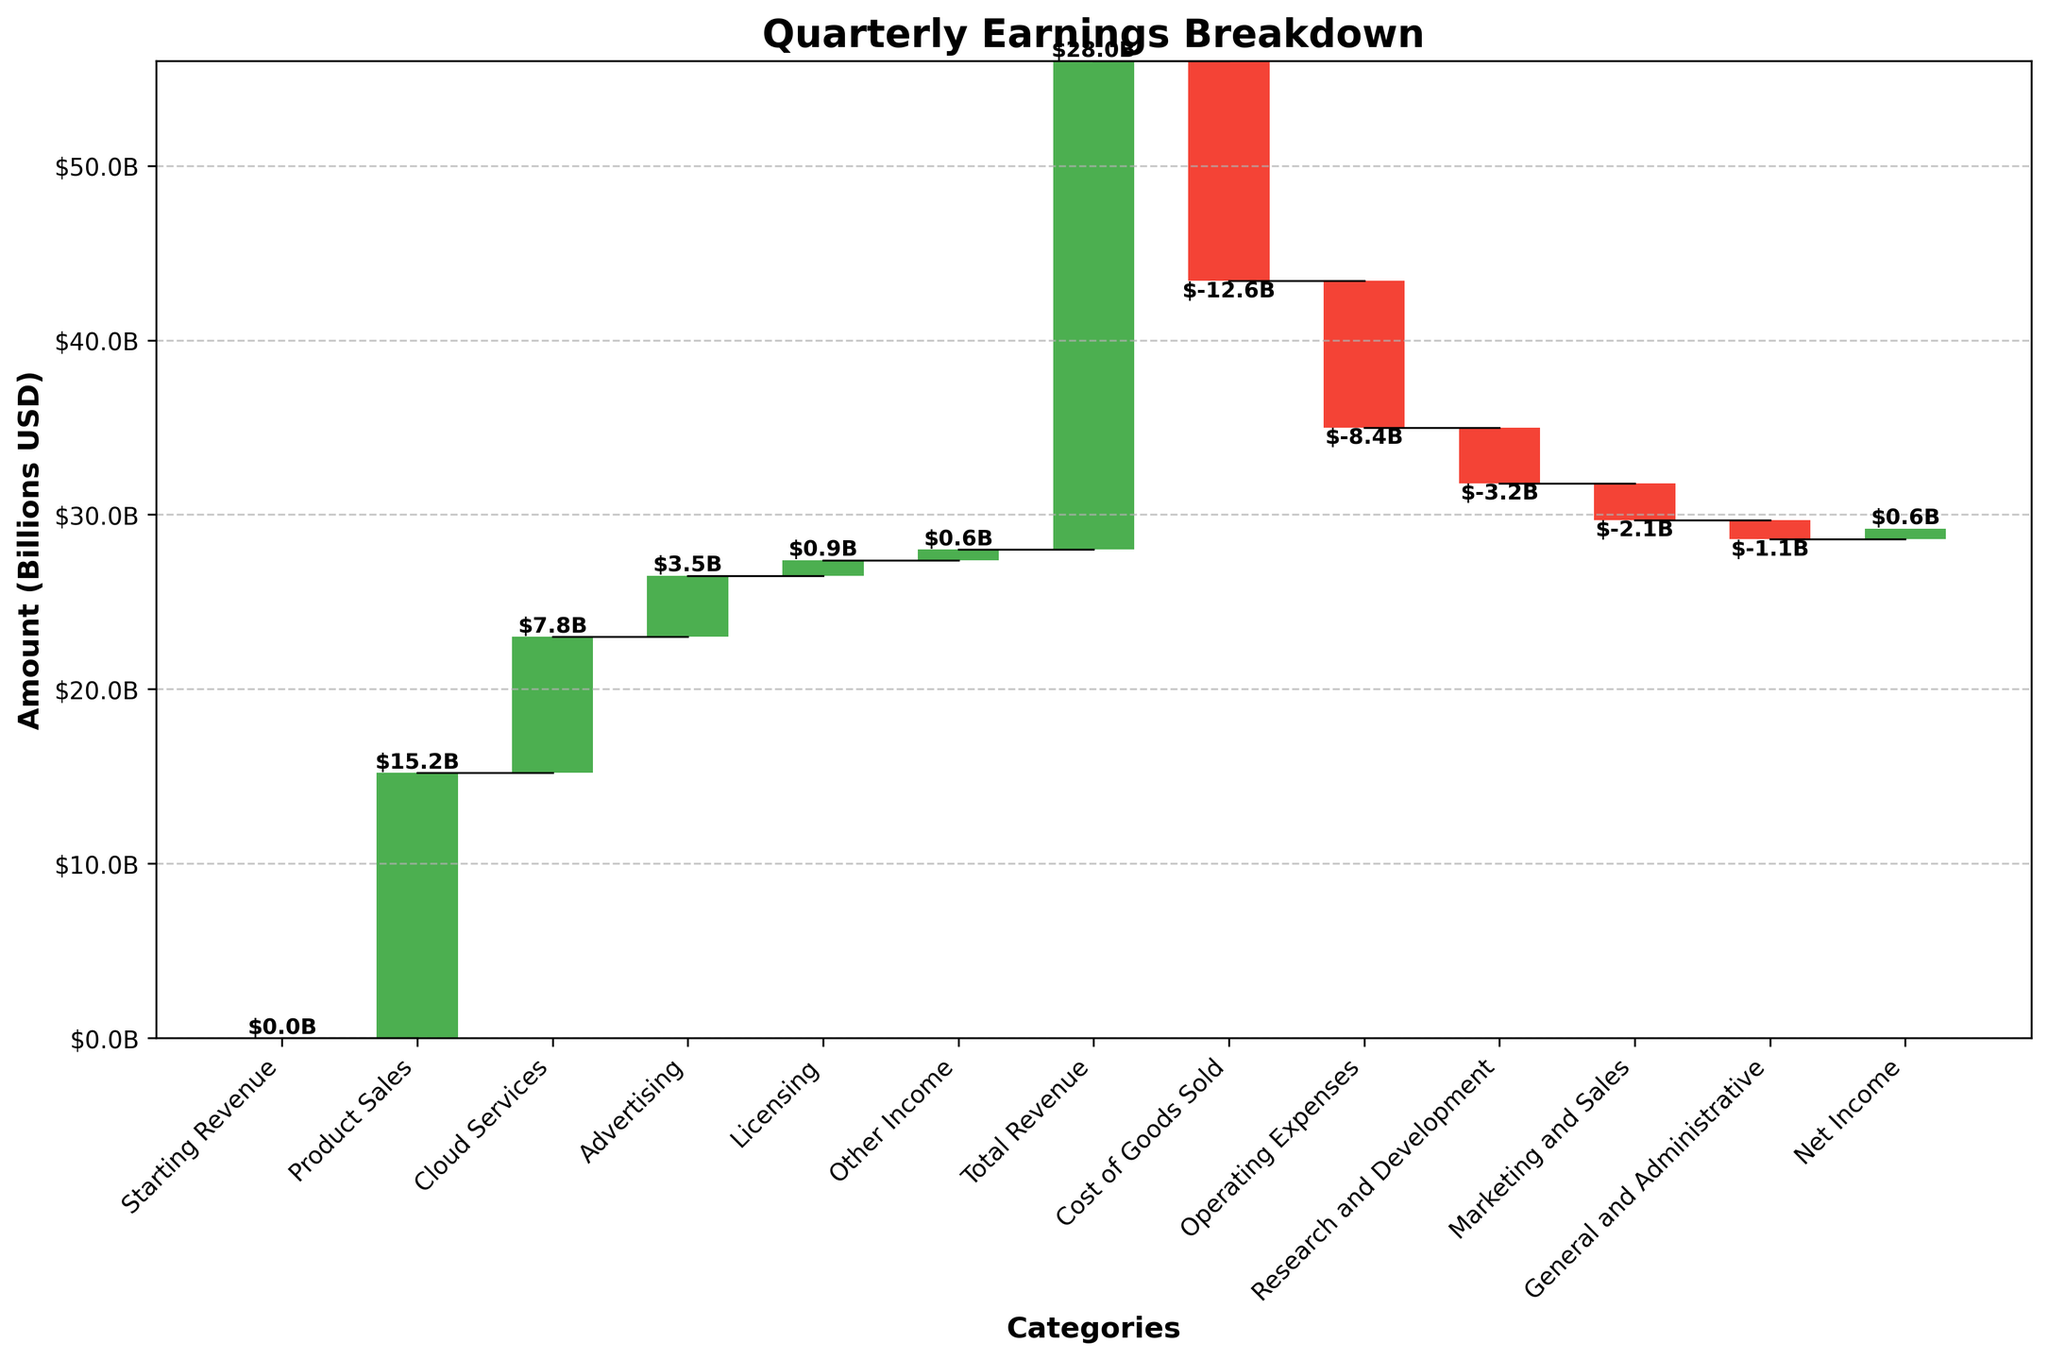What does the title of the Waterfall Chart mention? The title of the chart is located at the top and usually describes the overall subject of the chart. This particular chart's title provides context about what the data represents.
Answer: Quarterly Earnings Breakdown What is the total revenue as shown in the Waterfall Chart? The total revenue is represented as a single bar towards the beginning sections of the chart and is distinctly labeled. By looking at this bar's label, one can identify the total revenue amount.
Answer: $28.0B Why is "Cost of Goods Sold" represented with a red bar? In a Waterfall Chart, red bars typically indicate negative values which denote expenses or reductions in revenue. Hence, "Cost of Goods Sold" being in red signifies it is an expense.
Answer: It is an expense Which category is the largest expense in the breakdown? Locate the tallest bar in red on the negative side, as it indicates the largest expense. The label on this bar shows the specific category of the expense.
Answer: Cost of Goods Sold What step directly follows the "Starting Revenue" bar in the Waterfall Chart? The starting position on the Waterfall Chart leads to the first category that indicates revenue generation, marked by a green bar. This category is the first step after "Starting Revenue".
Answer: Product Sales Between "Research and Development" and "General and Administrative", which has a larger negative impact on net income? Compare the heights of the respective red bars for "Research and Development" and "General and Administrative". The taller bar indicates a larger impact.
Answer: Research and Development How does "Advertising" revenue compare to "Licensing" revenue? Look at the heights of the green bars labeled "Advertising" and "Licensing". The revenue from these categories can be directly compared by their heights.
Answer: Advertising revenue is higher 